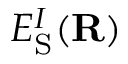Convert formula to latex. <formula><loc_0><loc_0><loc_500><loc_500>E _ { S } ^ { I } ( { R } )</formula> 